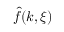Convert formula to latex. <formula><loc_0><loc_0><loc_500><loc_500>\hat { f } ( k , \xi )</formula> 